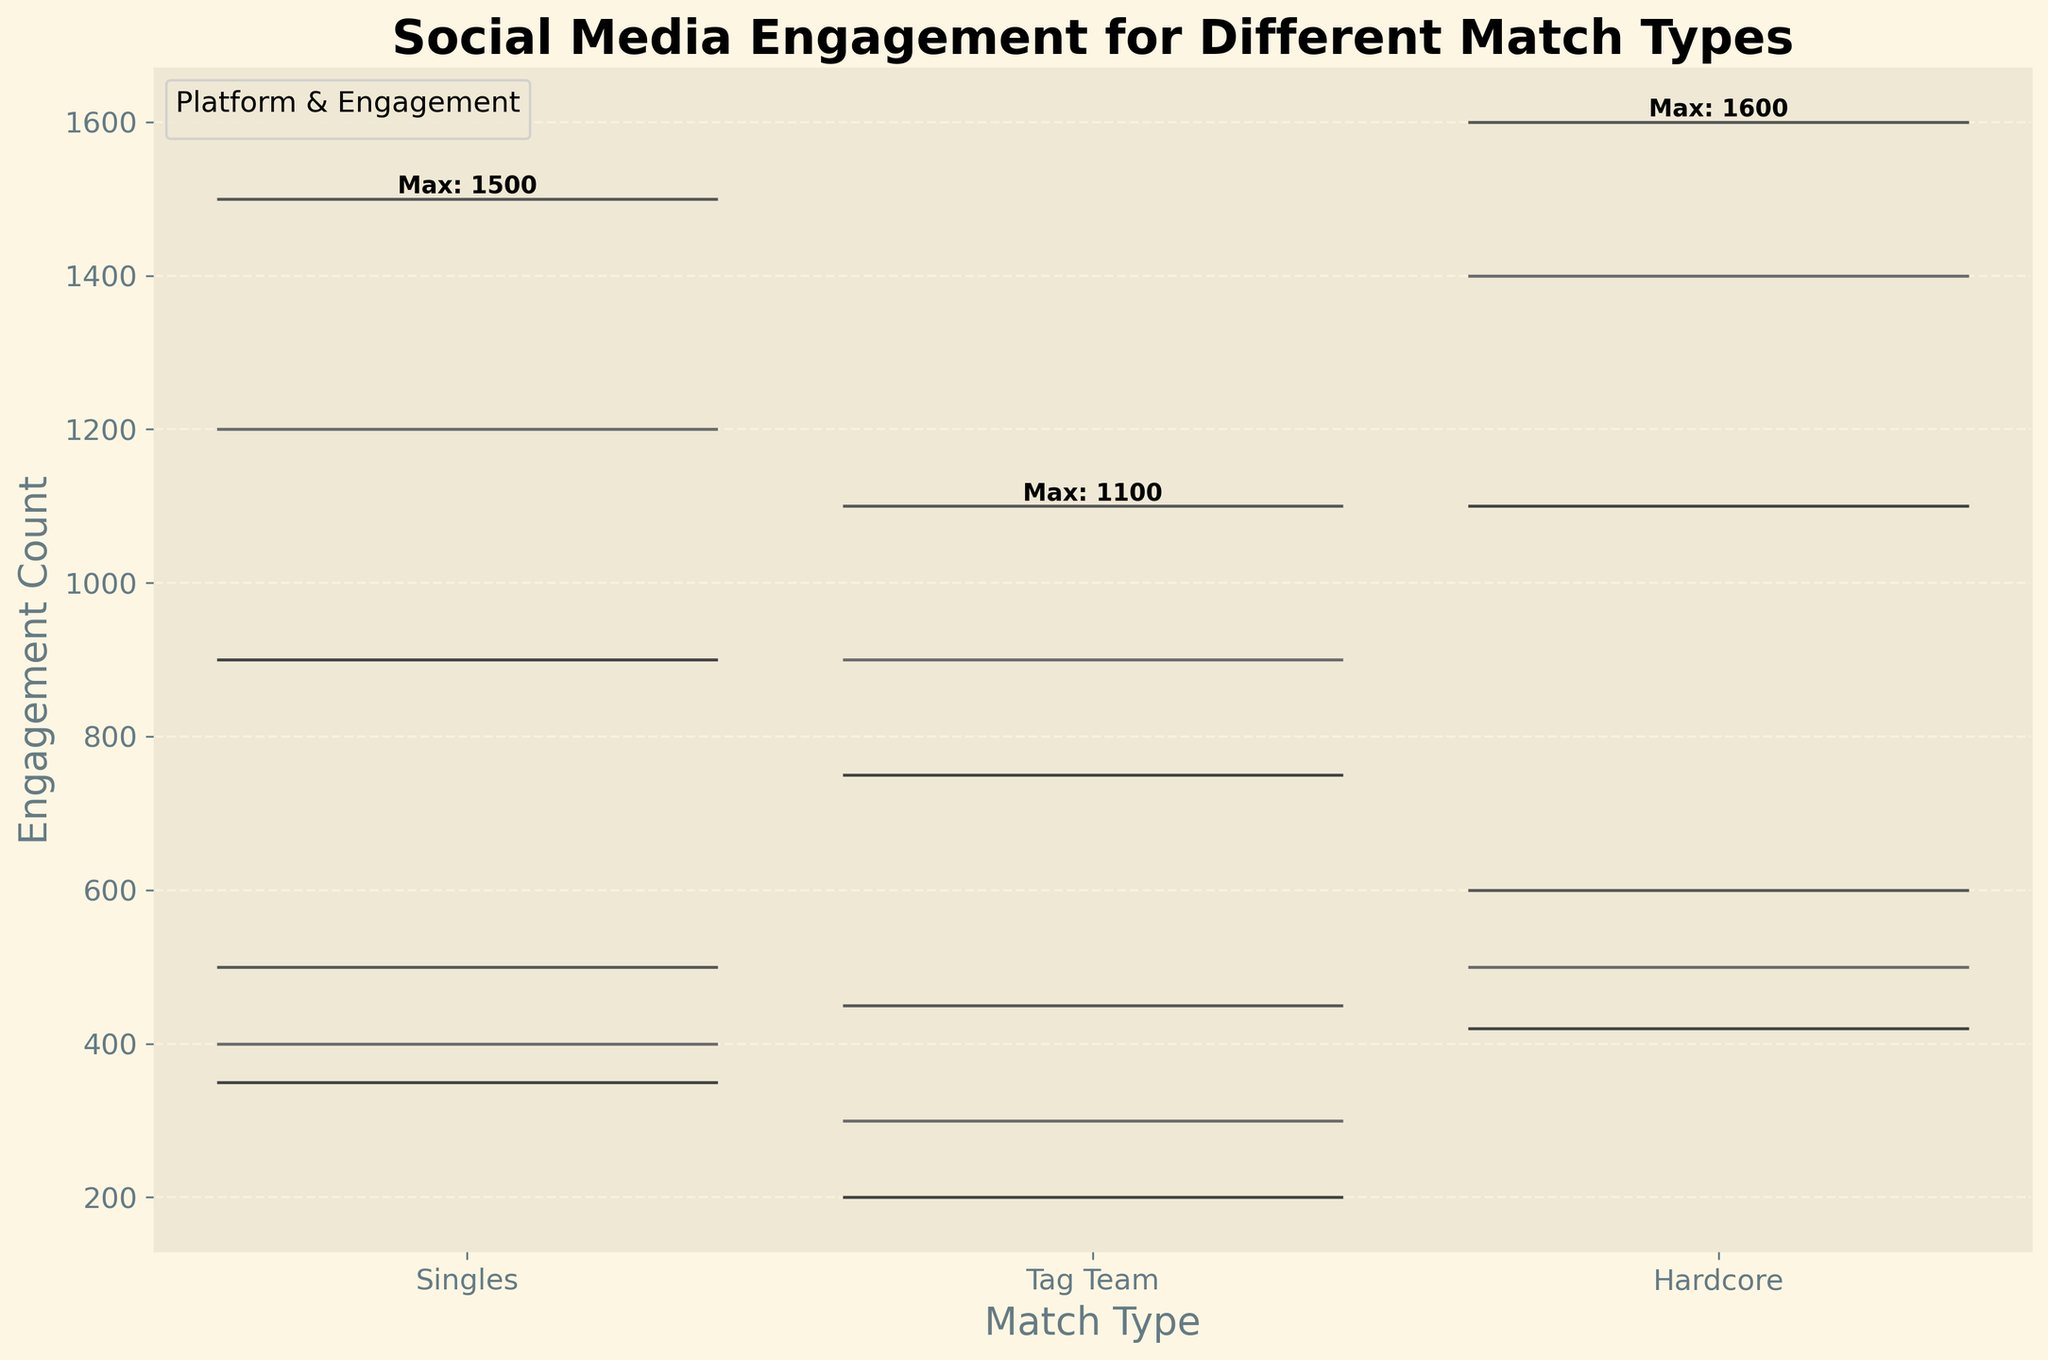How many types of matches are shown in the figure? There are three different types of matches shown on the x-axis. These are "Singles," "Tag Team," and "Hardcore."
Answer: 3 Which match type has the highest social media engagement on Instagram for likes? Look at the violin plot segments for Instagram likes across the three match types. The segment with the highest peak is for the "Hardcore" match type.
Answer: Hardcore What is the maximum engagement count for Singles matches? The maximum value can be found by looking for the highest peak in the "Singles" category. According to the text annotations, it is stated directly as "Max: 1500."
Answer: 1500 Which platform shows a higher average engagement for Shares in Hardcore matches compared to Likes? Calculate the average engagement for both Shares and Likes across the platforms for the "Hardcore" match type. Shares (Facebook: 500, Twitter: 420, Instagram: 600) are fewer in number but Instagram Shares (600) appear higher than Instagram Likes (1600). Thus, none of the platforms has a higher average engagement for Shares compared to Likes.
Answer: None What color represents Twitter Shares in the figure? The colors representing different platforms and engagement types can be identified by checking the legend. According to the legend, Twitter Shares appear in the same color assigned to "Twitter," which is a certain hue from the palette used.
Answer: Corresponding color from the legend How does the engagement count for Facebook Likes in Tag Team matches compare to Singles and Hardcore matches? Look at the peaks of the Facebook Likes sections for Singles, Tag Team, and Hardcore matches. Facebook Likes for Tag Team (900) are lower than both Singles (1200) and Hardcore (1400).
Answer: Lower than both Which match type has the lowest engagement count for Twitter Shares? Identify the lowest value from the violin plot for Twitter Shares across the three match types. The "Tag Team" match type appears to have the lowest peak at 200.
Answer: Tag Team How is the distribution of Instagram Likes different from Facebook Shares for Singles matches? Examine the spread and shape of the violin plots for Instagram Likes and Facebook Shares under the "Singles" match type. Instagram Likes show a higher, more spread-out peak compared to the relatively lower and narrower peak for Facebook Shares.
Answer: Higher and more spread-out for Instagram Likes Does Instagram engagement (Likes and Shares combined) show lower variation for Hardcore matches compared to Singles matches? Check the spread of the violin plots for both Likes and Shares on Instagram for Hardcore and Singles matches. The "Hardcore" matches show a more condensed plot compared to a wider spread for "Singles" matches, indicating lower variation.
Answer: Yes What is the engagement count difference between Facebook Likes and Twitter Likes for Hardcore matches? Compare the height of the violin plots for Facebook Likes and Twitter Likes under the "Hardcore" match type. Facebook Likes peak at 1400 and Twitter Likes at 1100. Calculate the difference: 1400 - 1100.
Answer: 300 